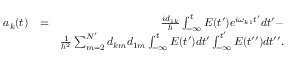Convert formula to latex. <formula><loc_0><loc_0><loc_500><loc_500>\begin{array} { r l r } { a _ { k } ( t ) } & { = } & { \frac { i d _ { 1 k } } { } \int _ { - \infty } ^ { t } E ( t ^ { \prime } ) e ^ { i \omega _ { k 1 } t ^ { \prime } } d t ^ { \prime } - } \\ & { \frac { 1 } { \hbar { ^ } { 2 } } \sum _ { m = 2 } ^ { N ^ { \prime } } d _ { k m } d _ { 1 m } \int _ { - \infty } ^ { t } E ( t ^ { \prime } ) d t ^ { \prime } \int _ { - \infty } ^ { t ^ { \prime } } E ( t ^ { \prime \prime } ) d t ^ { \prime \prime } . } \end{array}</formula> 